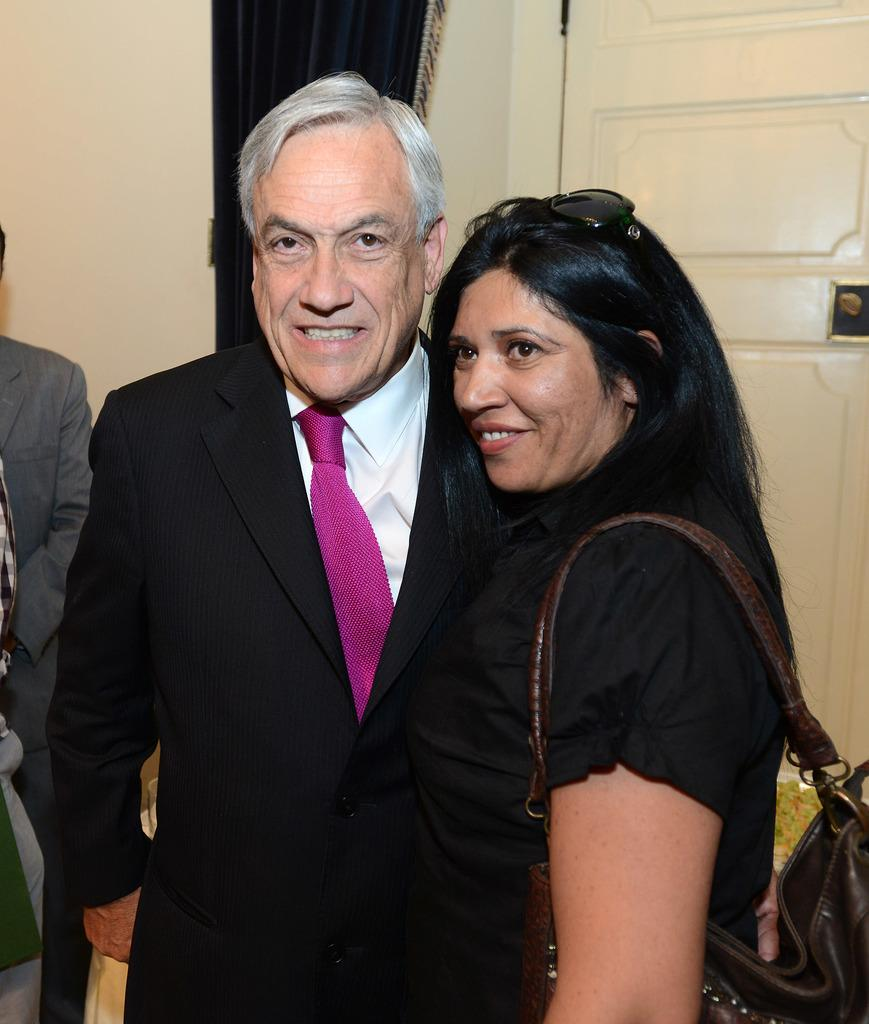What is the person in the image wearing? The person is wearing a black coat and a pink tie. What is the facial expression of the person in the image? The person is smiling. What is the lady in the image wearing? The lady is wearing a hand band and goggles. What is the facial expression of the lady in the image? The lady is smiling. What can be seen in the background of the image? There is a wall, a curtain, and a door in the background of the image. What type of reaction can be seen from the ant in the image? There are no ants present in the image, so it is not possible to determine any reaction from an ant. 